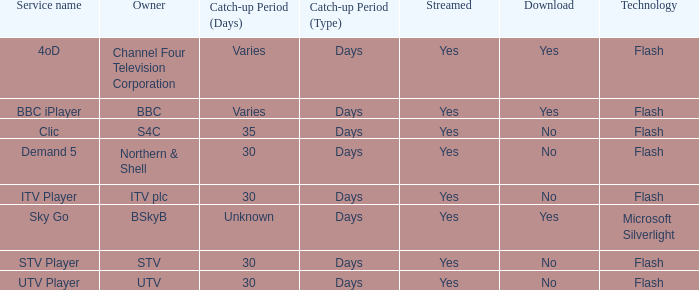What is the Service name of BBC? BBC iPlayer. 